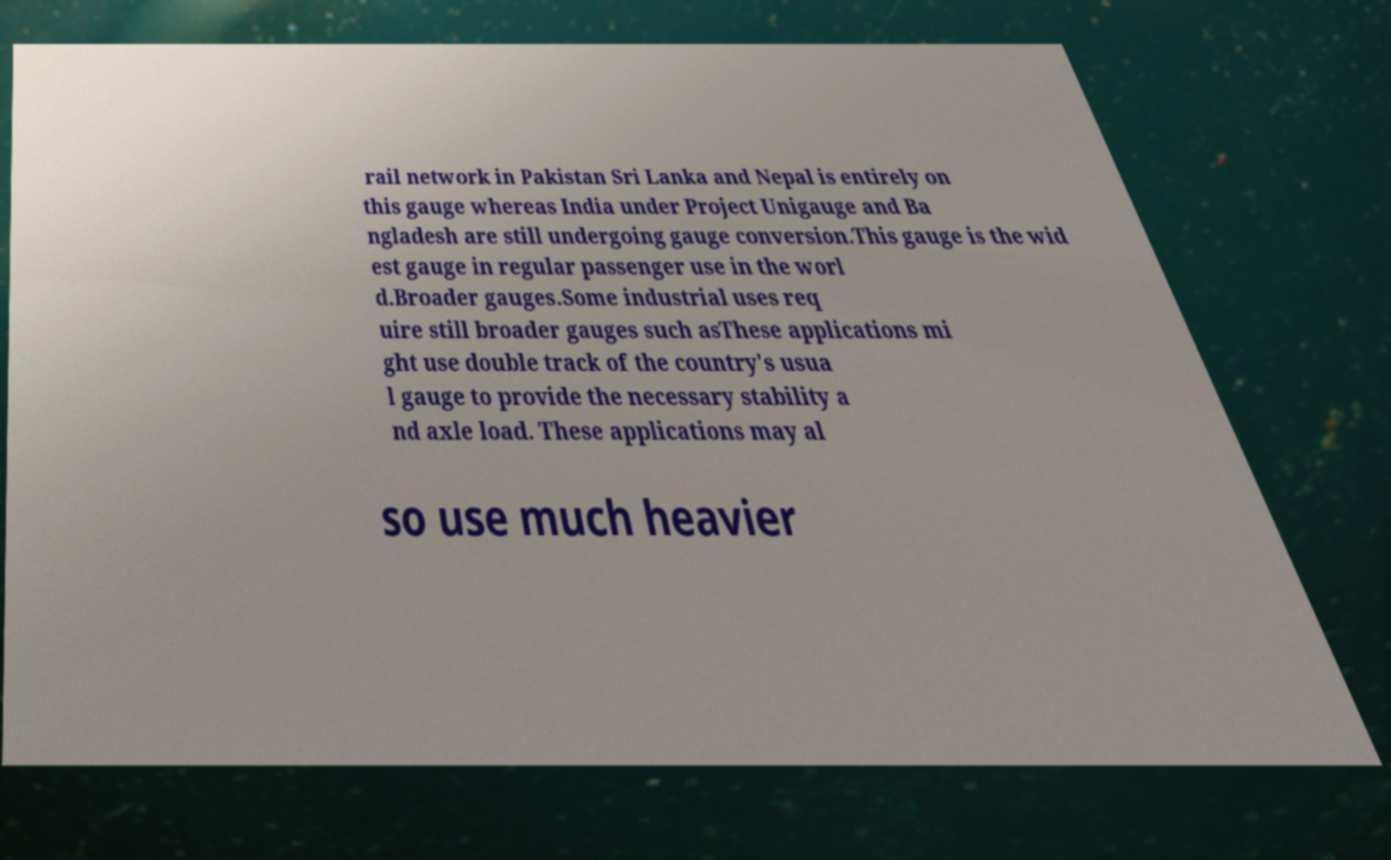Could you extract and type out the text from this image? rail network in Pakistan Sri Lanka and Nepal is entirely on this gauge whereas India under Project Unigauge and Ba ngladesh are still undergoing gauge conversion.This gauge is the wid est gauge in regular passenger use in the worl d.Broader gauges.Some industrial uses req uire still broader gauges such asThese applications mi ght use double track of the country's usua l gauge to provide the necessary stability a nd axle load. These applications may al so use much heavier 